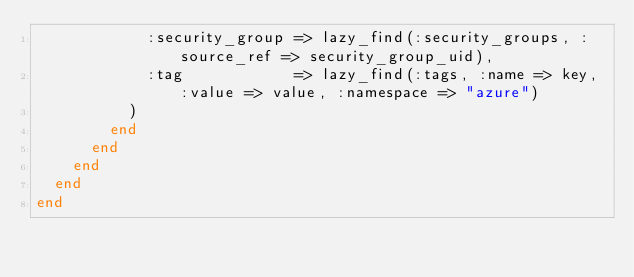<code> <loc_0><loc_0><loc_500><loc_500><_Ruby_>            :security_group => lazy_find(:security_groups, :source_ref => security_group_uid),
            :tag            => lazy_find(:tags, :name => key, :value => value, :namespace => "azure")
          )
        end
      end
    end
  end
end
</code> 